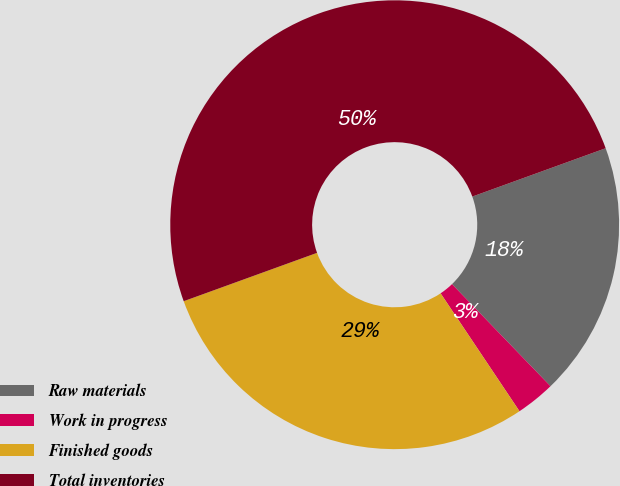<chart> <loc_0><loc_0><loc_500><loc_500><pie_chart><fcel>Raw materials<fcel>Work in progress<fcel>Finished goods<fcel>Total inventories<nl><fcel>18.32%<fcel>2.83%<fcel>28.85%<fcel>50.0%<nl></chart> 